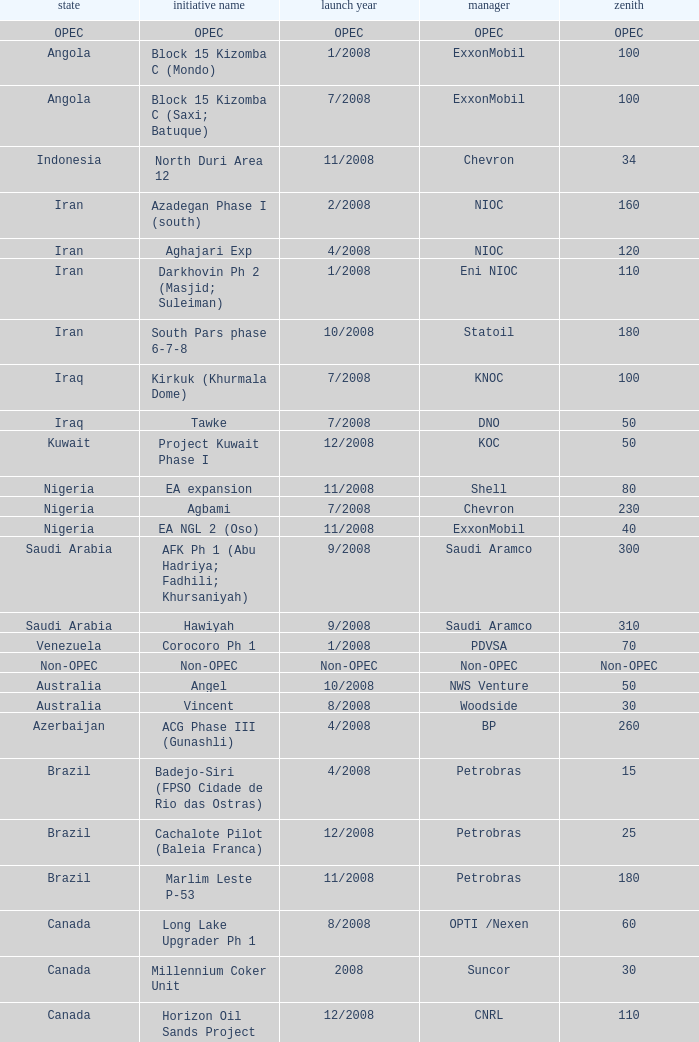What is the Project Name with a Country that is kazakhstan and a Peak that is 150? Dunga. 